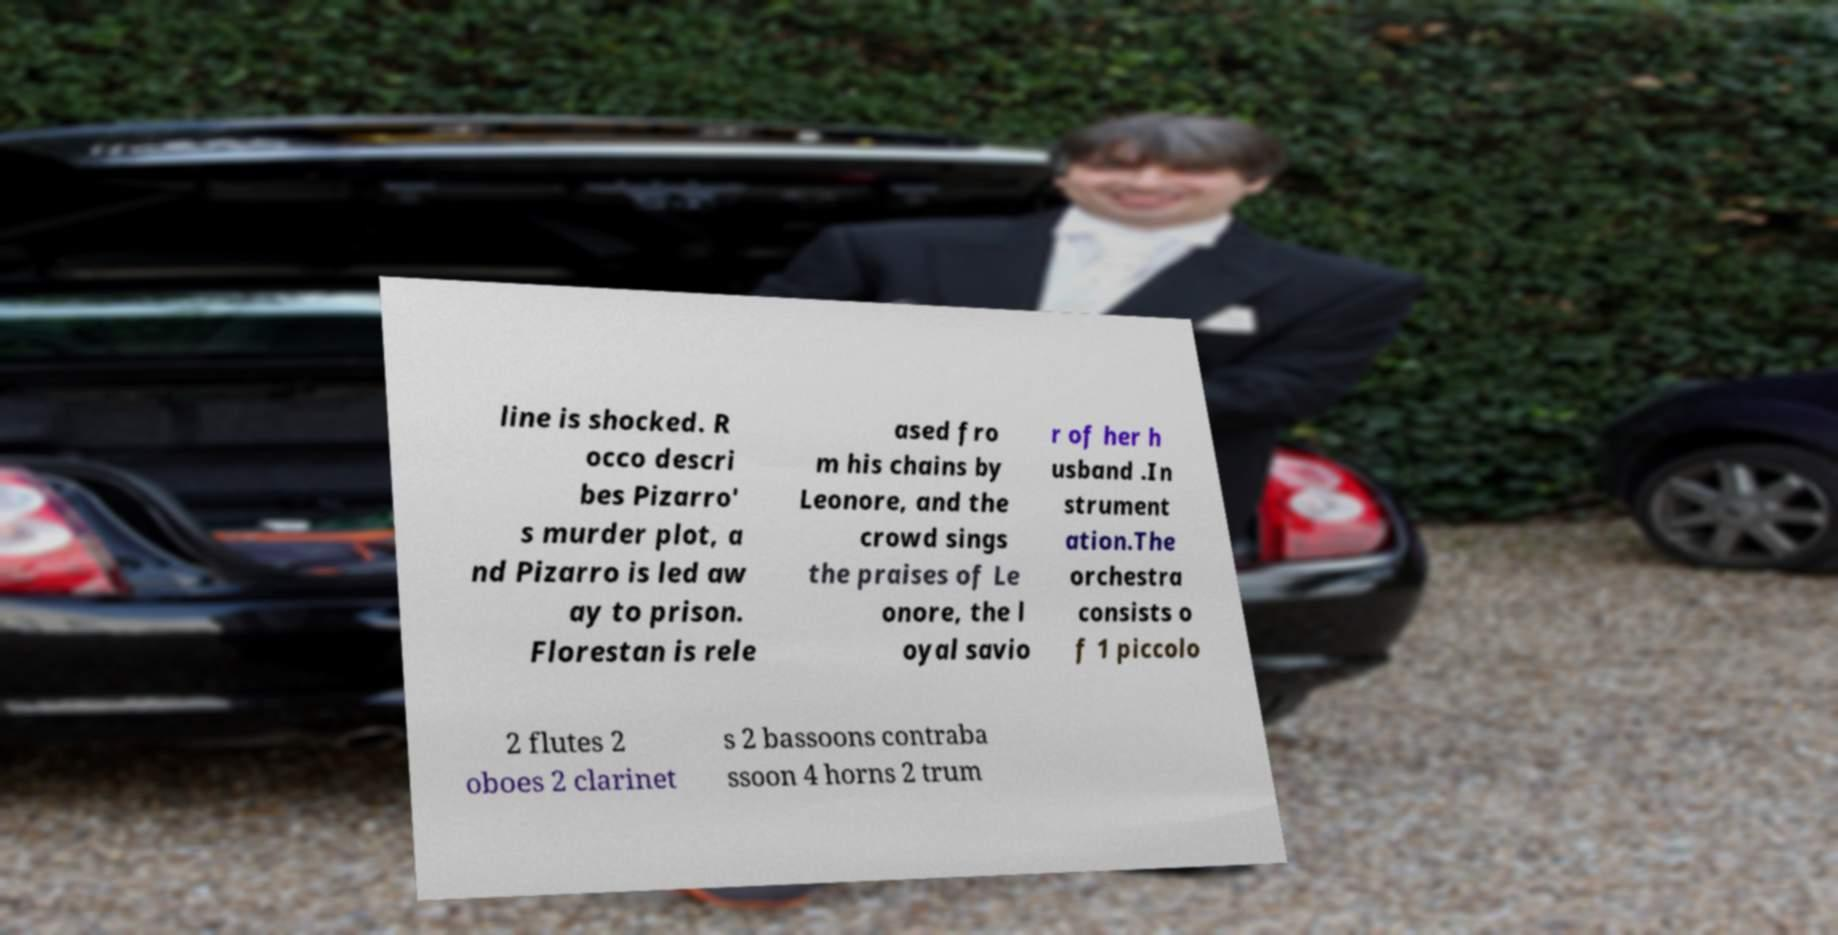Can you accurately transcribe the text from the provided image for me? line is shocked. R occo descri bes Pizarro' s murder plot, a nd Pizarro is led aw ay to prison. Florestan is rele ased fro m his chains by Leonore, and the crowd sings the praises of Le onore, the l oyal savio r of her h usband .In strument ation.The orchestra consists o f 1 piccolo 2 flutes 2 oboes 2 clarinet s 2 bassoons contraba ssoon 4 horns 2 trum 